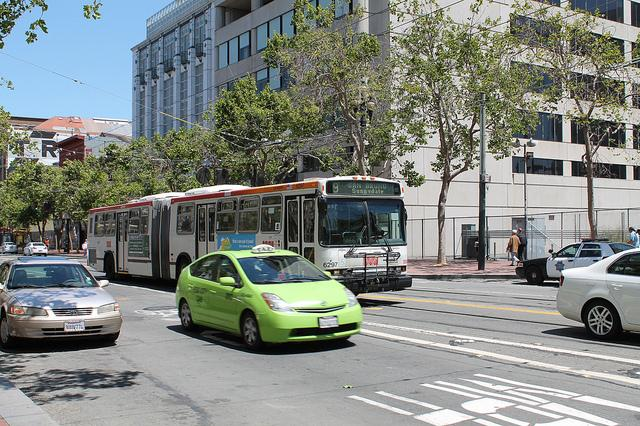Why is one car such a bright unusual color?

Choices:
A) taxi
B) fashionable
C) highlighter company
D) promotion taxi 